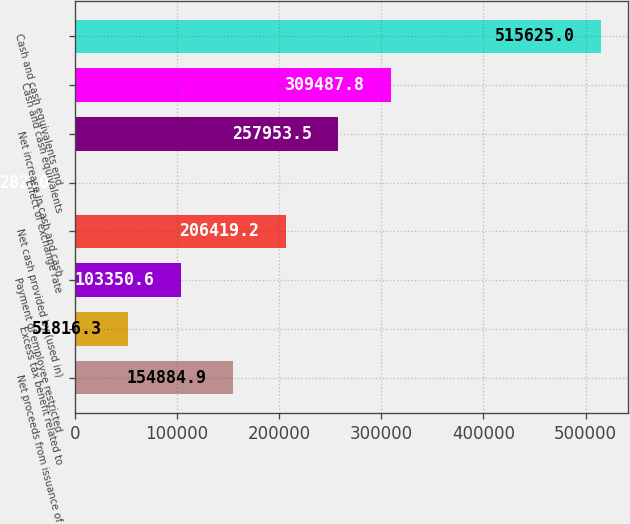<chart> <loc_0><loc_0><loc_500><loc_500><bar_chart><fcel>Net proceeds from issuance of<fcel>Excess tax benefit related to<fcel>Payment of employee restricted<fcel>Net cash provided by (used in)<fcel>Effect of exchange rate<fcel>Net increase in cash and cash<fcel>Cash and cash equivalents<fcel>Cash and cash equivalents end<nl><fcel>154885<fcel>51816.3<fcel>103351<fcel>206419<fcel>282<fcel>257954<fcel>309488<fcel>515625<nl></chart> 